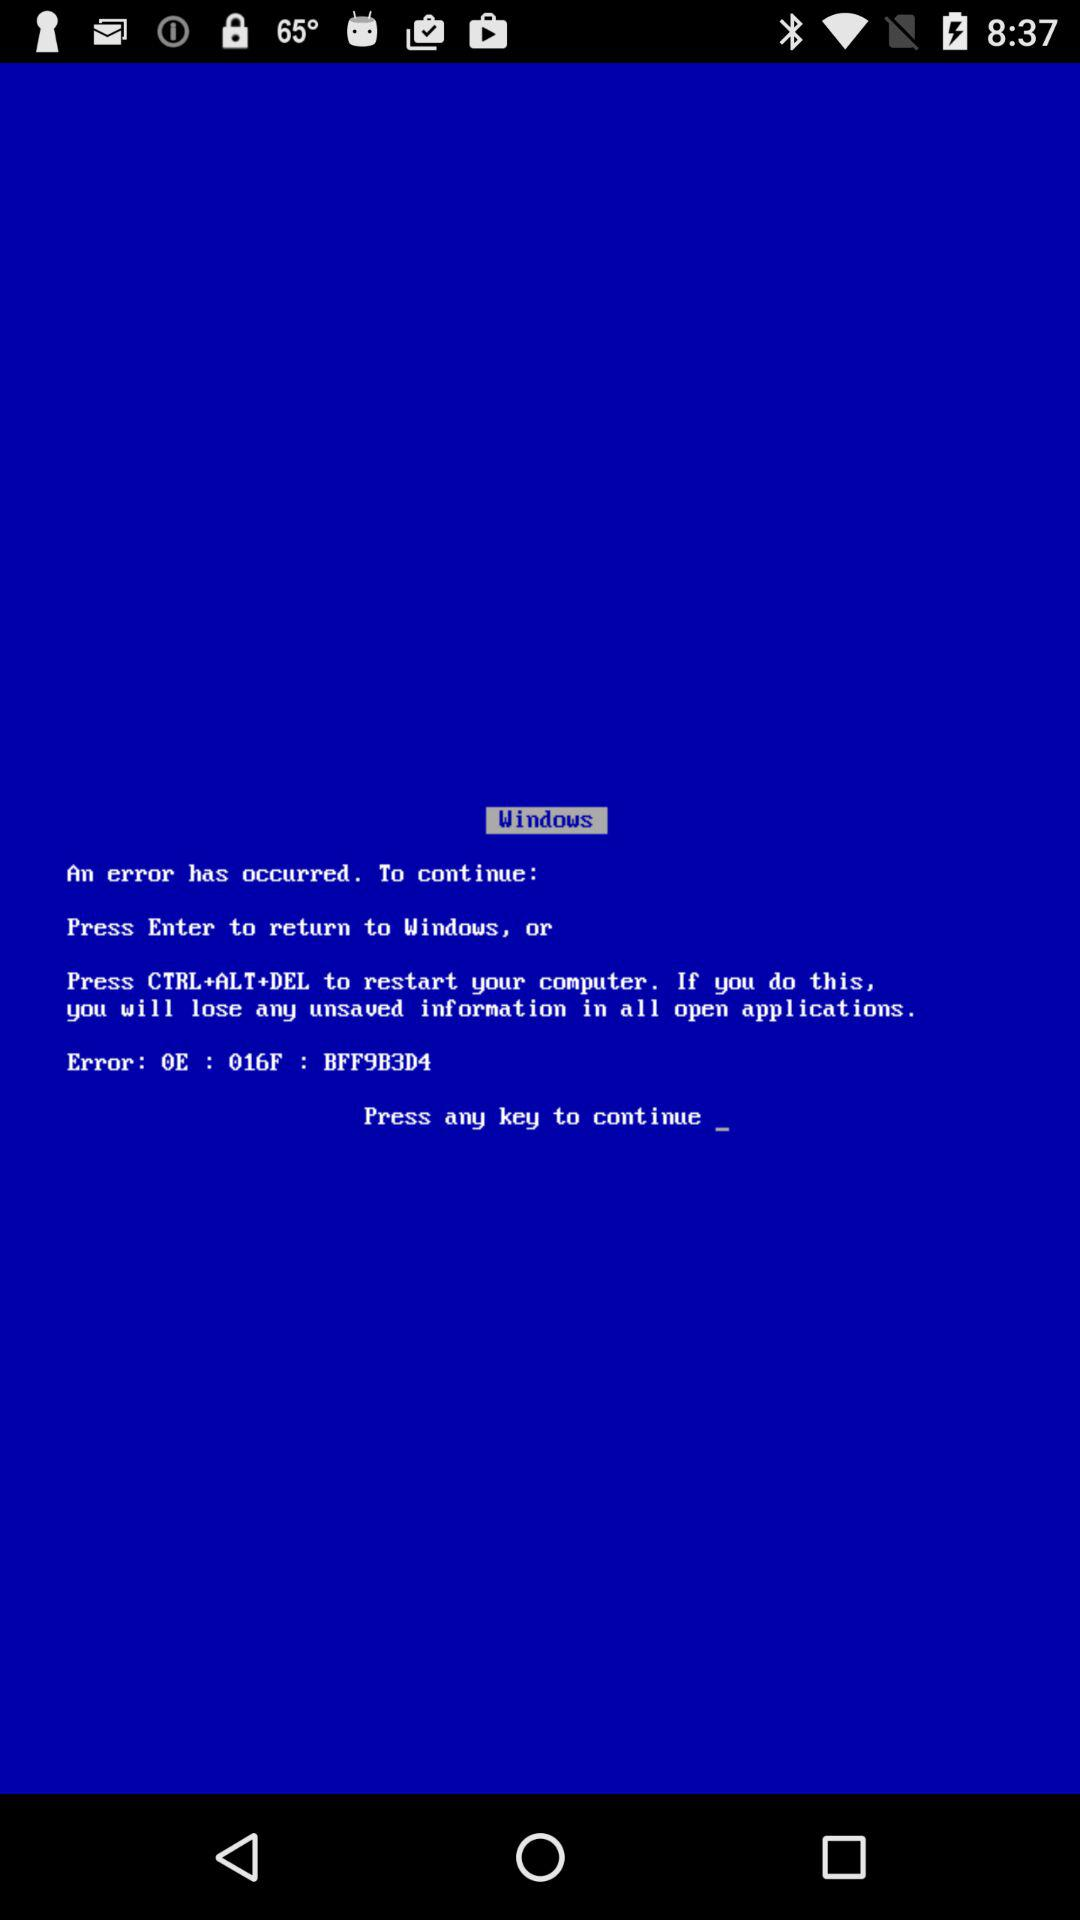How many options are there to continue?
Answer the question using a single word or phrase. 2 